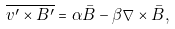<formula> <loc_0><loc_0><loc_500><loc_500>\overline { { v } ^ { \prime } \times { B } ^ { \prime } } = \alpha { \bar { B } } - \beta \nabla \times { \bar { B } } ,</formula> 